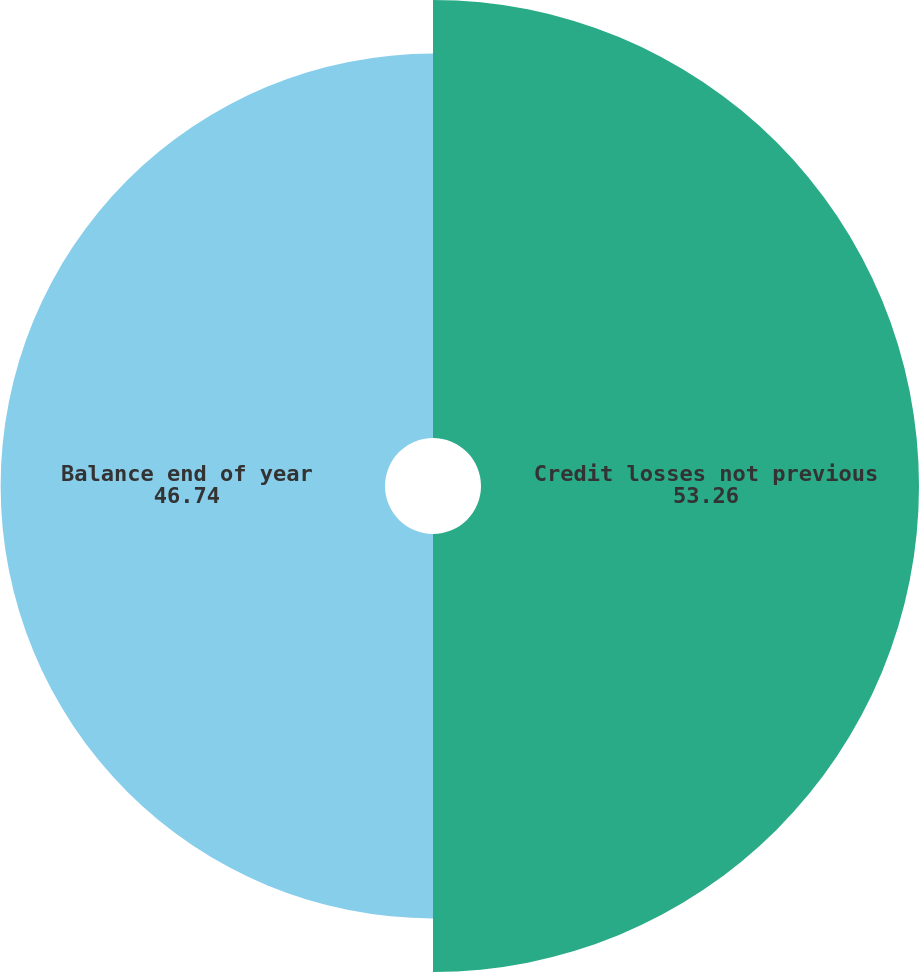Convert chart to OTSL. <chart><loc_0><loc_0><loc_500><loc_500><pie_chart><fcel>Credit losses not previous<fcel>Balance end of year<nl><fcel>53.26%<fcel>46.74%<nl></chart> 